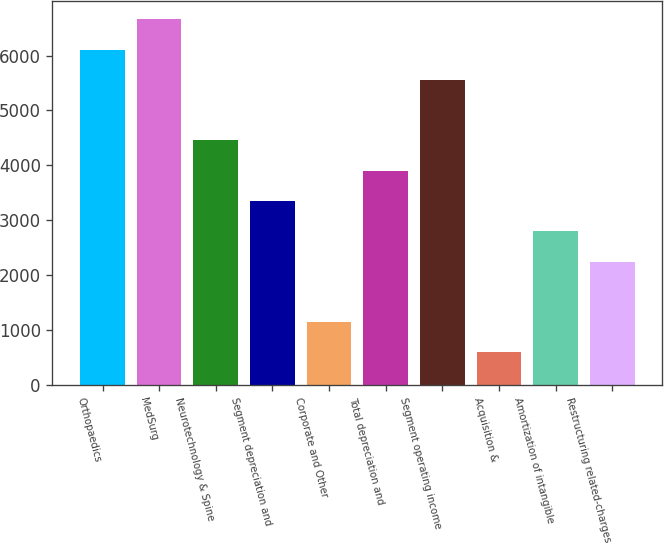<chart> <loc_0><loc_0><loc_500><loc_500><bar_chart><fcel>Orthopaedics<fcel>MedSurg<fcel>Neurotechnology & Spine<fcel>Segment depreciation and<fcel>Corporate and Other<fcel>Total depreciation and<fcel>Segment operating income<fcel>Acquisition &<fcel>Amortization of intangible<fcel>Restructuring related-charges<nl><fcel>6108.8<fcel>6660.6<fcel>4453.4<fcel>3349.8<fcel>1142.6<fcel>3901.6<fcel>5557<fcel>590.8<fcel>2798<fcel>2246.2<nl></chart> 